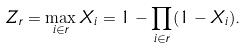<formula> <loc_0><loc_0><loc_500><loc_500>Z _ { r } = \max _ { i \in r } X _ { i } = 1 - \prod _ { i \in r } ( 1 - X _ { i } ) .</formula> 